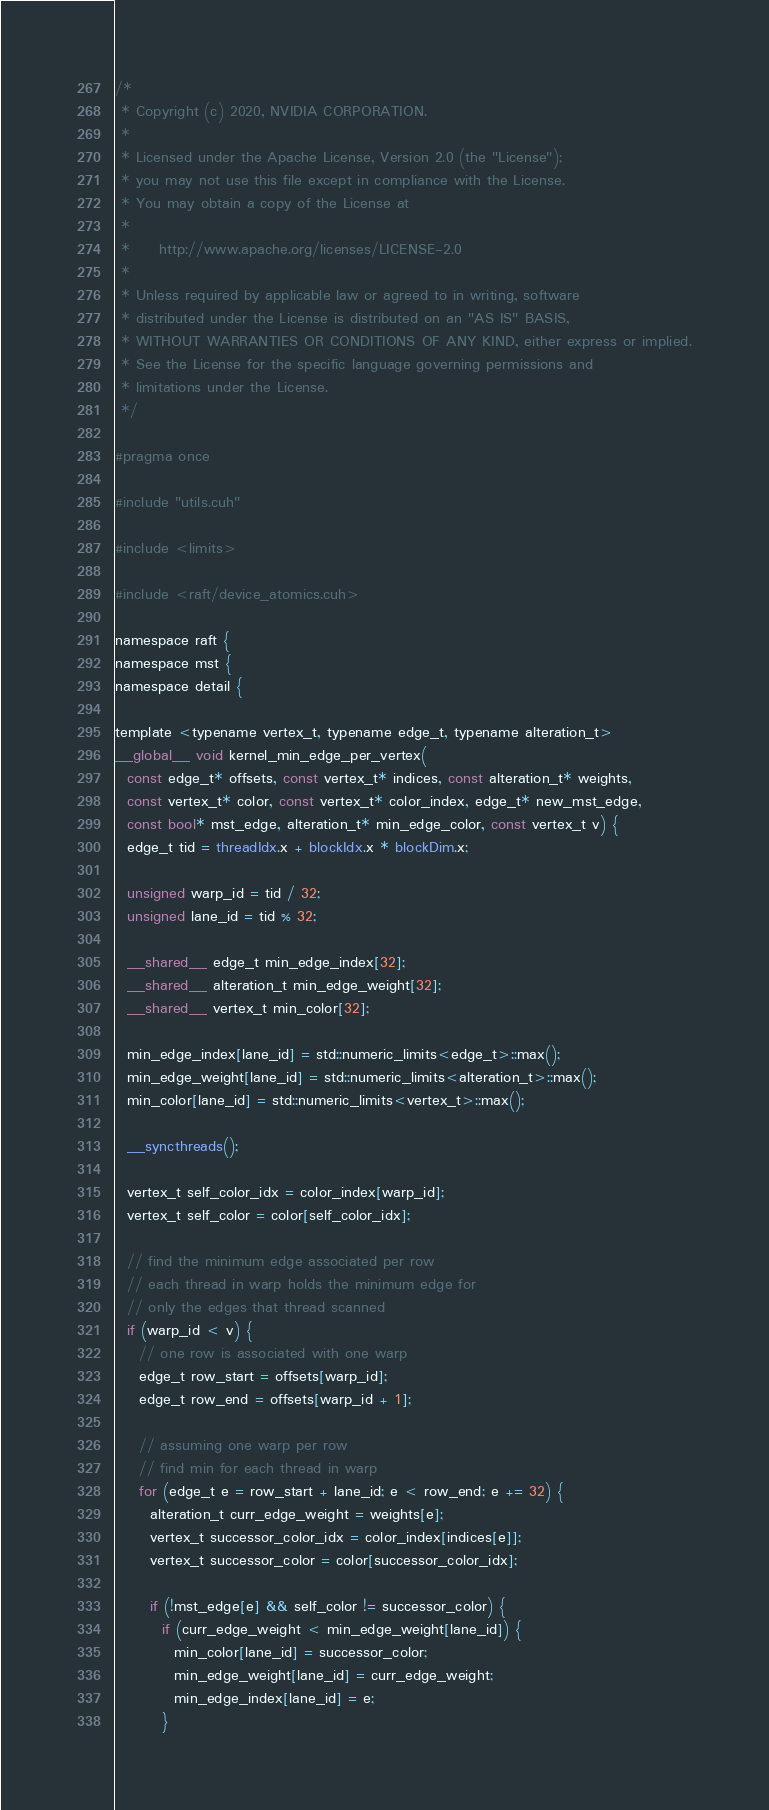<code> <loc_0><loc_0><loc_500><loc_500><_Cuda_>
/*
 * Copyright (c) 2020, NVIDIA CORPORATION.
 *
 * Licensed under the Apache License, Version 2.0 (the "License");
 * you may not use this file except in compliance with the License.
 * You may obtain a copy of the License at
 *
 *     http://www.apache.org/licenses/LICENSE-2.0
 *
 * Unless required by applicable law or agreed to in writing, software
 * distributed under the License is distributed on an "AS IS" BASIS,
 * WITHOUT WARRANTIES OR CONDITIONS OF ANY KIND, either express or implied.
 * See the License for the specific language governing permissions and
 * limitations under the License.
 */

#pragma once

#include "utils.cuh"

#include <limits>

#include <raft/device_atomics.cuh>

namespace raft {
namespace mst {
namespace detail {

template <typename vertex_t, typename edge_t, typename alteration_t>
__global__ void kernel_min_edge_per_vertex(
  const edge_t* offsets, const vertex_t* indices, const alteration_t* weights,
  const vertex_t* color, const vertex_t* color_index, edge_t* new_mst_edge,
  const bool* mst_edge, alteration_t* min_edge_color, const vertex_t v) {
  edge_t tid = threadIdx.x + blockIdx.x * blockDim.x;

  unsigned warp_id = tid / 32;
  unsigned lane_id = tid % 32;

  __shared__ edge_t min_edge_index[32];
  __shared__ alteration_t min_edge_weight[32];
  __shared__ vertex_t min_color[32];

  min_edge_index[lane_id] = std::numeric_limits<edge_t>::max();
  min_edge_weight[lane_id] = std::numeric_limits<alteration_t>::max();
  min_color[lane_id] = std::numeric_limits<vertex_t>::max();

  __syncthreads();

  vertex_t self_color_idx = color_index[warp_id];
  vertex_t self_color = color[self_color_idx];

  // find the minimum edge associated per row
  // each thread in warp holds the minimum edge for
  // only the edges that thread scanned
  if (warp_id < v) {
    // one row is associated with one warp
    edge_t row_start = offsets[warp_id];
    edge_t row_end = offsets[warp_id + 1];

    // assuming one warp per row
    // find min for each thread in warp
    for (edge_t e = row_start + lane_id; e < row_end; e += 32) {
      alteration_t curr_edge_weight = weights[e];
      vertex_t successor_color_idx = color_index[indices[e]];
      vertex_t successor_color = color[successor_color_idx];

      if (!mst_edge[e] && self_color != successor_color) {
        if (curr_edge_weight < min_edge_weight[lane_id]) {
          min_color[lane_id] = successor_color;
          min_edge_weight[lane_id] = curr_edge_weight;
          min_edge_index[lane_id] = e;
        }</code> 